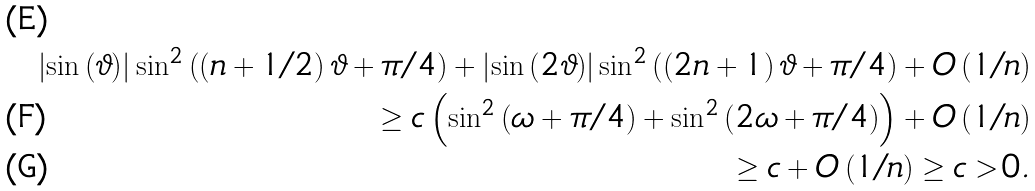<formula> <loc_0><loc_0><loc_500><loc_500>\left | \sin \left ( \vartheta \right ) \right | \sin ^ { 2 } \left ( \left ( n + 1 / 2 \right ) \vartheta + \pi / 4 \right ) + \left | \sin \left ( 2 \vartheta \right ) \right | \sin ^ { 2 } \left ( \left ( 2 n + 1 \right ) \vartheta + \pi / 4 \right ) + O \left ( 1 / n \right ) \\ \geq c \left ( \sin ^ { 2 } \left ( \omega + \pi / 4 \right ) + \sin ^ { 2 } \left ( 2 \omega + \pi / 4 \right ) \right ) + O \left ( 1 / n \right ) \\ \geq c + O \left ( 1 / n \right ) \geq c > 0 .</formula> 